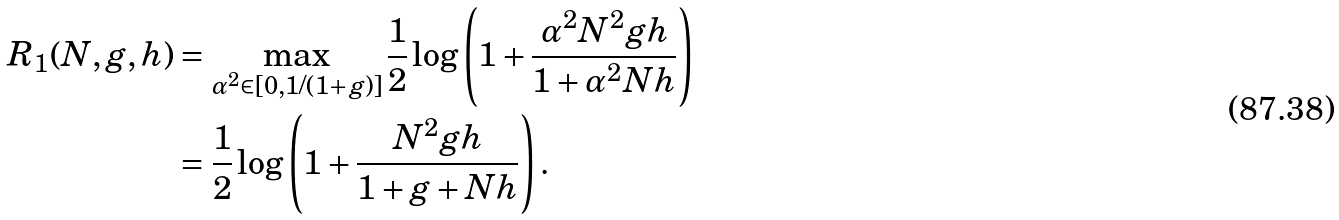Convert formula to latex. <formula><loc_0><loc_0><loc_500><loc_500>R _ { 1 } ( N , g , h ) & = \max _ { \alpha ^ { 2 } \in [ 0 , 1 / ( 1 + g ) ] } \frac { 1 } { 2 } \log \left ( 1 + \frac { \alpha ^ { 2 } N ^ { 2 } g h } { 1 + \alpha ^ { 2 } N h } \right ) \\ & = \frac { 1 } { 2 } \log \left ( 1 + \frac { N ^ { 2 } g h } { 1 + g + N h } \right ) .</formula> 